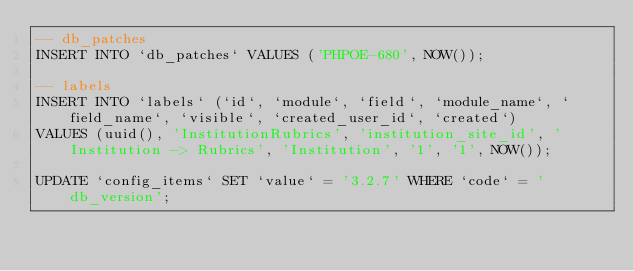<code> <loc_0><loc_0><loc_500><loc_500><_SQL_>-- db_patches
INSERT INTO `db_patches` VALUES ('PHPOE-680', NOW());

-- labels
INSERT INTO `labels` (`id`, `module`, `field`, `module_name`, `field_name`, `visible`, `created_user_id`, `created`) 
VALUES (uuid(), 'InstitutionRubrics', 'institution_site_id', 'Institution -> Rubrics', 'Institution', '1', '1', NOW());

UPDATE `config_items` SET `value` = '3.2.7' WHERE `code` = 'db_version';
</code> 